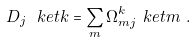<formula> <loc_0><loc_0><loc_500><loc_500>D _ { j } \ k e t { k } & = \sum _ { m } \Omega ^ { k } _ { m j } \ k e t { m } \ .</formula> 